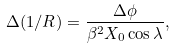<formula> <loc_0><loc_0><loc_500><loc_500>\Delta ( 1 / R ) = \frac { \Delta \phi } { \beta ^ { 2 } X _ { 0 } \cos { \lambda } } ,</formula> 